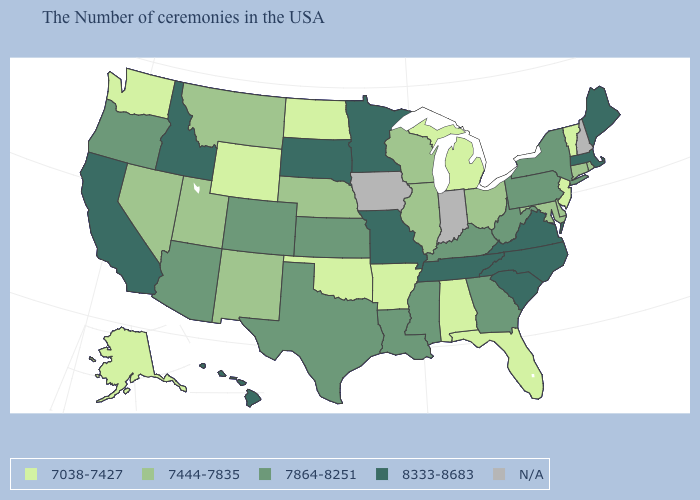Does Maine have the highest value in the Northeast?
Quick response, please. Yes. Name the states that have a value in the range 7444-7835?
Short answer required. Rhode Island, Connecticut, Delaware, Maryland, Ohio, Wisconsin, Illinois, Nebraska, New Mexico, Utah, Montana, Nevada. What is the lowest value in the USA?
Concise answer only. 7038-7427. What is the value of Louisiana?
Quick response, please. 7864-8251. Among the states that border Oregon , does Nevada have the lowest value?
Keep it brief. No. Among the states that border Maryland , which have the lowest value?
Keep it brief. Delaware. Name the states that have a value in the range 7864-8251?
Quick response, please. New York, Pennsylvania, West Virginia, Georgia, Kentucky, Mississippi, Louisiana, Kansas, Texas, Colorado, Arizona, Oregon. What is the highest value in the USA?
Concise answer only. 8333-8683. How many symbols are there in the legend?
Give a very brief answer. 5. Among the states that border New York , which have the highest value?
Write a very short answer. Massachusetts. What is the highest value in the USA?
Short answer required. 8333-8683. What is the value of Idaho?
Quick response, please. 8333-8683. Name the states that have a value in the range 8333-8683?
Concise answer only. Maine, Massachusetts, Virginia, North Carolina, South Carolina, Tennessee, Missouri, Minnesota, South Dakota, Idaho, California, Hawaii. Is the legend a continuous bar?
Short answer required. No. 